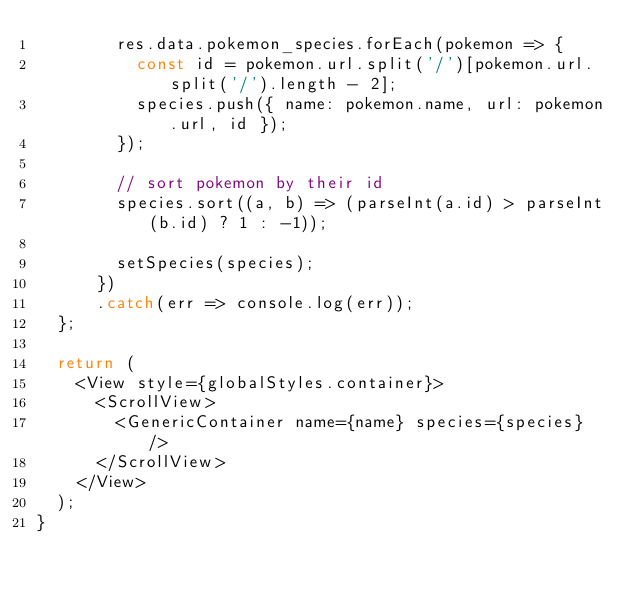<code> <loc_0><loc_0><loc_500><loc_500><_JavaScript_>        res.data.pokemon_species.forEach(pokemon => {
          const id = pokemon.url.split('/')[pokemon.url.split('/').length - 2];
          species.push({ name: pokemon.name, url: pokemon.url, id });
        });

        // sort pokemon by their id
        species.sort((a, b) => (parseInt(a.id) > parseInt(b.id) ? 1 : -1));

        setSpecies(species);
      })
      .catch(err => console.log(err));
  };

  return (
    <View style={globalStyles.container}>
      <ScrollView>
        <GenericContainer name={name} species={species} />
      </ScrollView>
    </View>
  );
}
</code> 